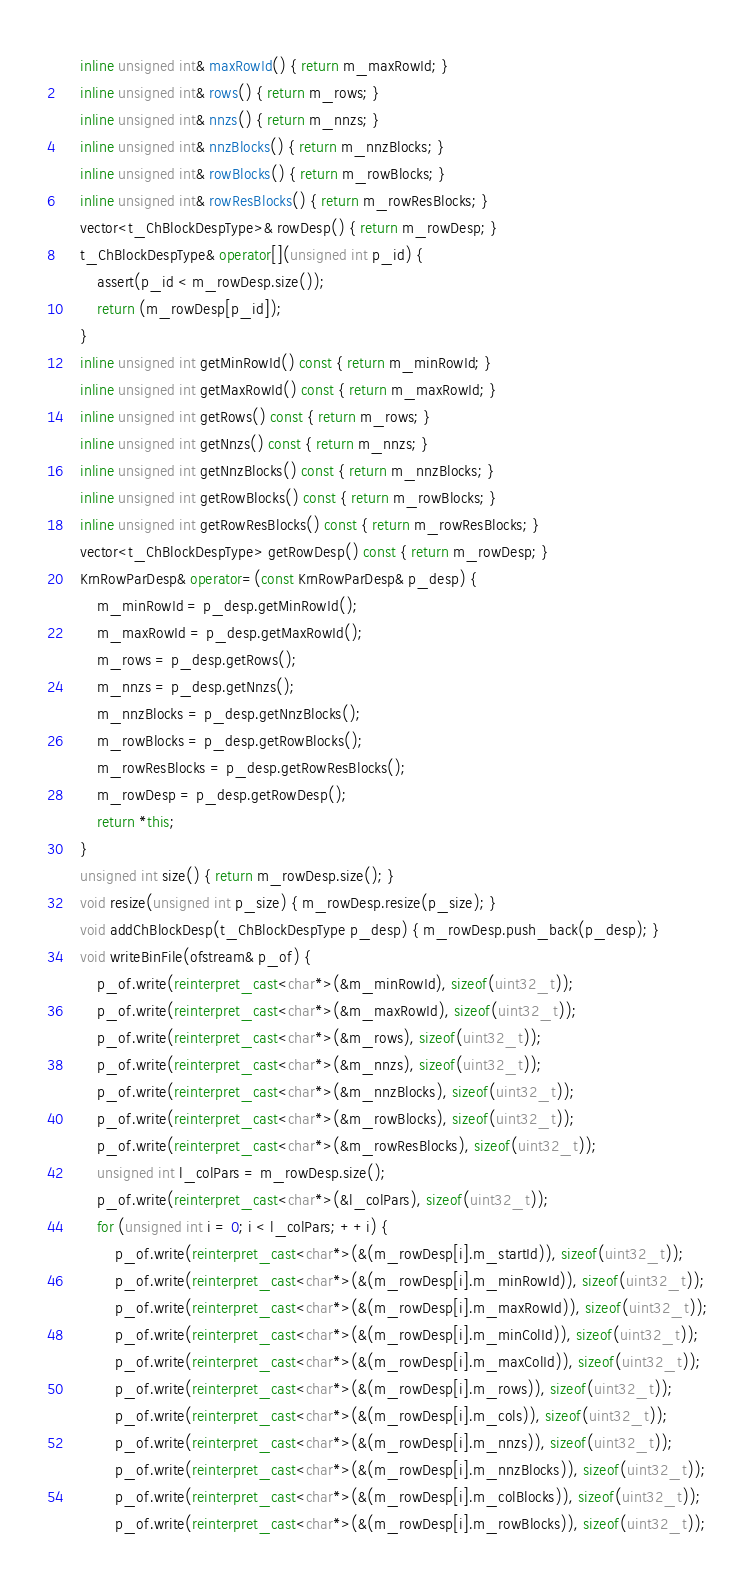Convert code to text. <code><loc_0><loc_0><loc_500><loc_500><_C++_>    inline unsigned int& maxRowId() { return m_maxRowId; }
    inline unsigned int& rows() { return m_rows; }
    inline unsigned int& nnzs() { return m_nnzs; }
    inline unsigned int& nnzBlocks() { return m_nnzBlocks; }
    inline unsigned int& rowBlocks() { return m_rowBlocks; }
    inline unsigned int& rowResBlocks() { return m_rowResBlocks; }
    vector<t_ChBlockDespType>& rowDesp() { return m_rowDesp; }
    t_ChBlockDespType& operator[](unsigned int p_id) {
        assert(p_id < m_rowDesp.size());
        return (m_rowDesp[p_id]);
    }
    inline unsigned int getMinRowId() const { return m_minRowId; }
    inline unsigned int getMaxRowId() const { return m_maxRowId; }
    inline unsigned int getRows() const { return m_rows; }
    inline unsigned int getNnzs() const { return m_nnzs; }
    inline unsigned int getNnzBlocks() const { return m_nnzBlocks; }
    inline unsigned int getRowBlocks() const { return m_rowBlocks; }
    inline unsigned int getRowResBlocks() const { return m_rowResBlocks; }
    vector<t_ChBlockDespType> getRowDesp() const { return m_rowDesp; }
    KrnRowParDesp& operator=(const KrnRowParDesp& p_desp) {
        m_minRowId = p_desp.getMinRowId();
        m_maxRowId = p_desp.getMaxRowId();
        m_rows = p_desp.getRows();
        m_nnzs = p_desp.getNnzs();
        m_nnzBlocks = p_desp.getNnzBlocks();
        m_rowBlocks = p_desp.getRowBlocks();
        m_rowResBlocks = p_desp.getRowResBlocks();
        m_rowDesp = p_desp.getRowDesp();
        return *this;
    }
    unsigned int size() { return m_rowDesp.size(); }
    void resize(unsigned int p_size) { m_rowDesp.resize(p_size); }
    void addChBlockDesp(t_ChBlockDespType p_desp) { m_rowDesp.push_back(p_desp); }
    void writeBinFile(ofstream& p_of) {
        p_of.write(reinterpret_cast<char*>(&m_minRowId), sizeof(uint32_t));
        p_of.write(reinterpret_cast<char*>(&m_maxRowId), sizeof(uint32_t));
        p_of.write(reinterpret_cast<char*>(&m_rows), sizeof(uint32_t));
        p_of.write(reinterpret_cast<char*>(&m_nnzs), sizeof(uint32_t));
        p_of.write(reinterpret_cast<char*>(&m_nnzBlocks), sizeof(uint32_t));
        p_of.write(reinterpret_cast<char*>(&m_rowBlocks), sizeof(uint32_t));
        p_of.write(reinterpret_cast<char*>(&m_rowResBlocks), sizeof(uint32_t));
        unsigned int l_colPars = m_rowDesp.size();
        p_of.write(reinterpret_cast<char*>(&l_colPars), sizeof(uint32_t));
        for (unsigned int i = 0; i < l_colPars; ++i) {
            p_of.write(reinterpret_cast<char*>(&(m_rowDesp[i].m_startId)), sizeof(uint32_t));
            p_of.write(reinterpret_cast<char*>(&(m_rowDesp[i].m_minRowId)), sizeof(uint32_t));
            p_of.write(reinterpret_cast<char*>(&(m_rowDesp[i].m_maxRowId)), sizeof(uint32_t));
            p_of.write(reinterpret_cast<char*>(&(m_rowDesp[i].m_minColId)), sizeof(uint32_t));
            p_of.write(reinterpret_cast<char*>(&(m_rowDesp[i].m_maxColId)), sizeof(uint32_t));
            p_of.write(reinterpret_cast<char*>(&(m_rowDesp[i].m_rows)), sizeof(uint32_t));
            p_of.write(reinterpret_cast<char*>(&(m_rowDesp[i].m_cols)), sizeof(uint32_t));
            p_of.write(reinterpret_cast<char*>(&(m_rowDesp[i].m_nnzs)), sizeof(uint32_t));
            p_of.write(reinterpret_cast<char*>(&(m_rowDesp[i].m_nnzBlocks)), sizeof(uint32_t));
            p_of.write(reinterpret_cast<char*>(&(m_rowDesp[i].m_colBlocks)), sizeof(uint32_t));
            p_of.write(reinterpret_cast<char*>(&(m_rowDesp[i].m_rowBlocks)), sizeof(uint32_t));</code> 